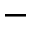<formula> <loc_0><loc_0><loc_500><loc_500>^ { - }</formula> 